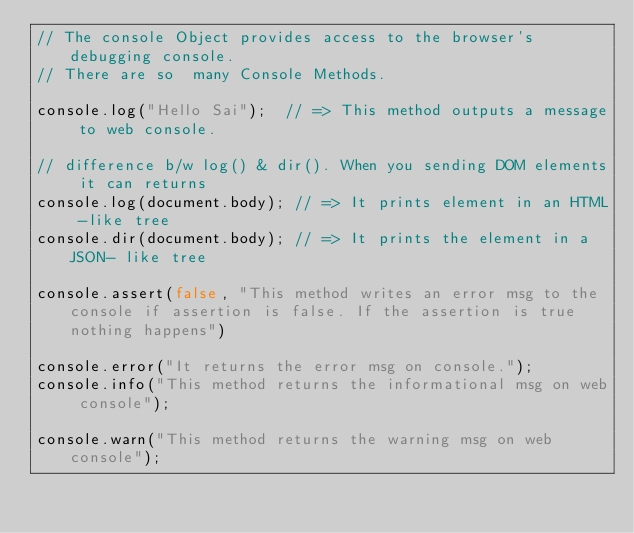<code> <loc_0><loc_0><loc_500><loc_500><_JavaScript_>// The console Object provides access to the browser's debugging console.
// There are so  many Console Methods.

console.log("Hello Sai");  // => This method outputs a message to web console.

// difference b/w log() & dir(). When you sending DOM elements it can returns
console.log(document.body); // => It prints element in an HTML -like tree
console.dir(document.body); // => It prints the element in a JSON- like tree

console.assert(false, "This method writes an error msg to the console if assertion is false. If the assertion is true nothing happens")

console.error("It returns the error msg on console.");
console.info("This method returns the informational msg on web console");

console.warn("This method returns the warning msg on web console");

</code> 